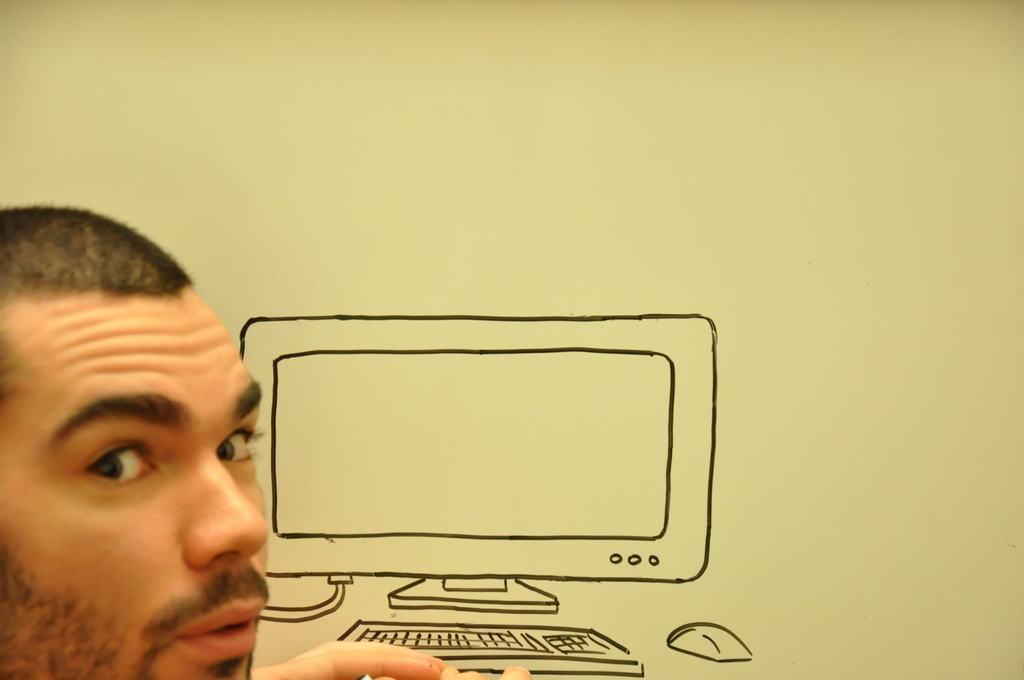Describe this image in one or two sentences. In this image I can see the person. In-front of the person I can see the drawing of the computer on the wall. 